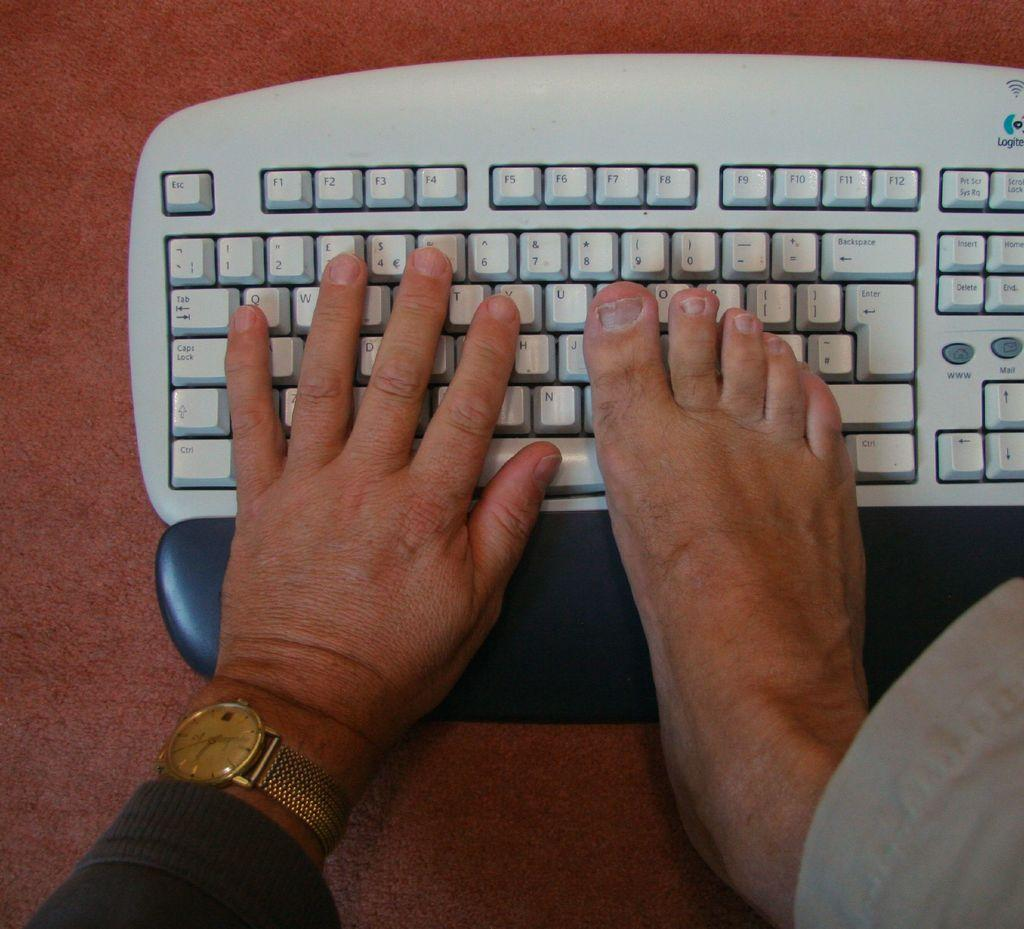<image>
Relay a brief, clear account of the picture shown. The brand of keyboard being used here is a Logitech 